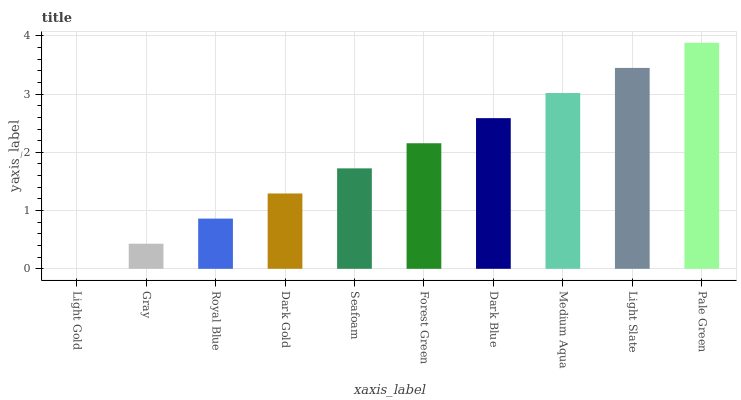Is Light Gold the minimum?
Answer yes or no. Yes. Is Pale Green the maximum?
Answer yes or no. Yes. Is Gray the minimum?
Answer yes or no. No. Is Gray the maximum?
Answer yes or no. No. Is Gray greater than Light Gold?
Answer yes or no. Yes. Is Light Gold less than Gray?
Answer yes or no. Yes. Is Light Gold greater than Gray?
Answer yes or no. No. Is Gray less than Light Gold?
Answer yes or no. No. Is Forest Green the high median?
Answer yes or no. Yes. Is Seafoam the low median?
Answer yes or no. Yes. Is Pale Green the high median?
Answer yes or no. No. Is Dark Gold the low median?
Answer yes or no. No. 